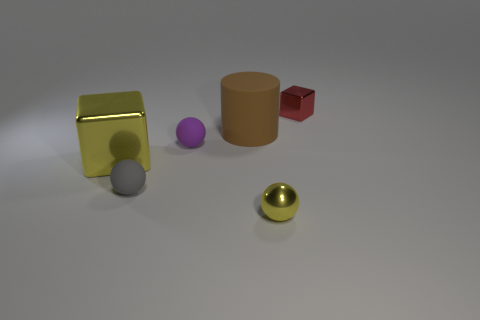Subtract all yellow cubes. Subtract all cyan balls. How many cubes are left? 1 Add 2 blue rubber blocks. How many objects exist? 8 Subtract all blocks. How many objects are left? 4 Add 6 large shiny cubes. How many large shiny cubes are left? 7 Add 1 big brown matte cylinders. How many big brown matte cylinders exist? 2 Subtract 0 green spheres. How many objects are left? 6 Subtract all tiny brown rubber blocks. Subtract all small objects. How many objects are left? 2 